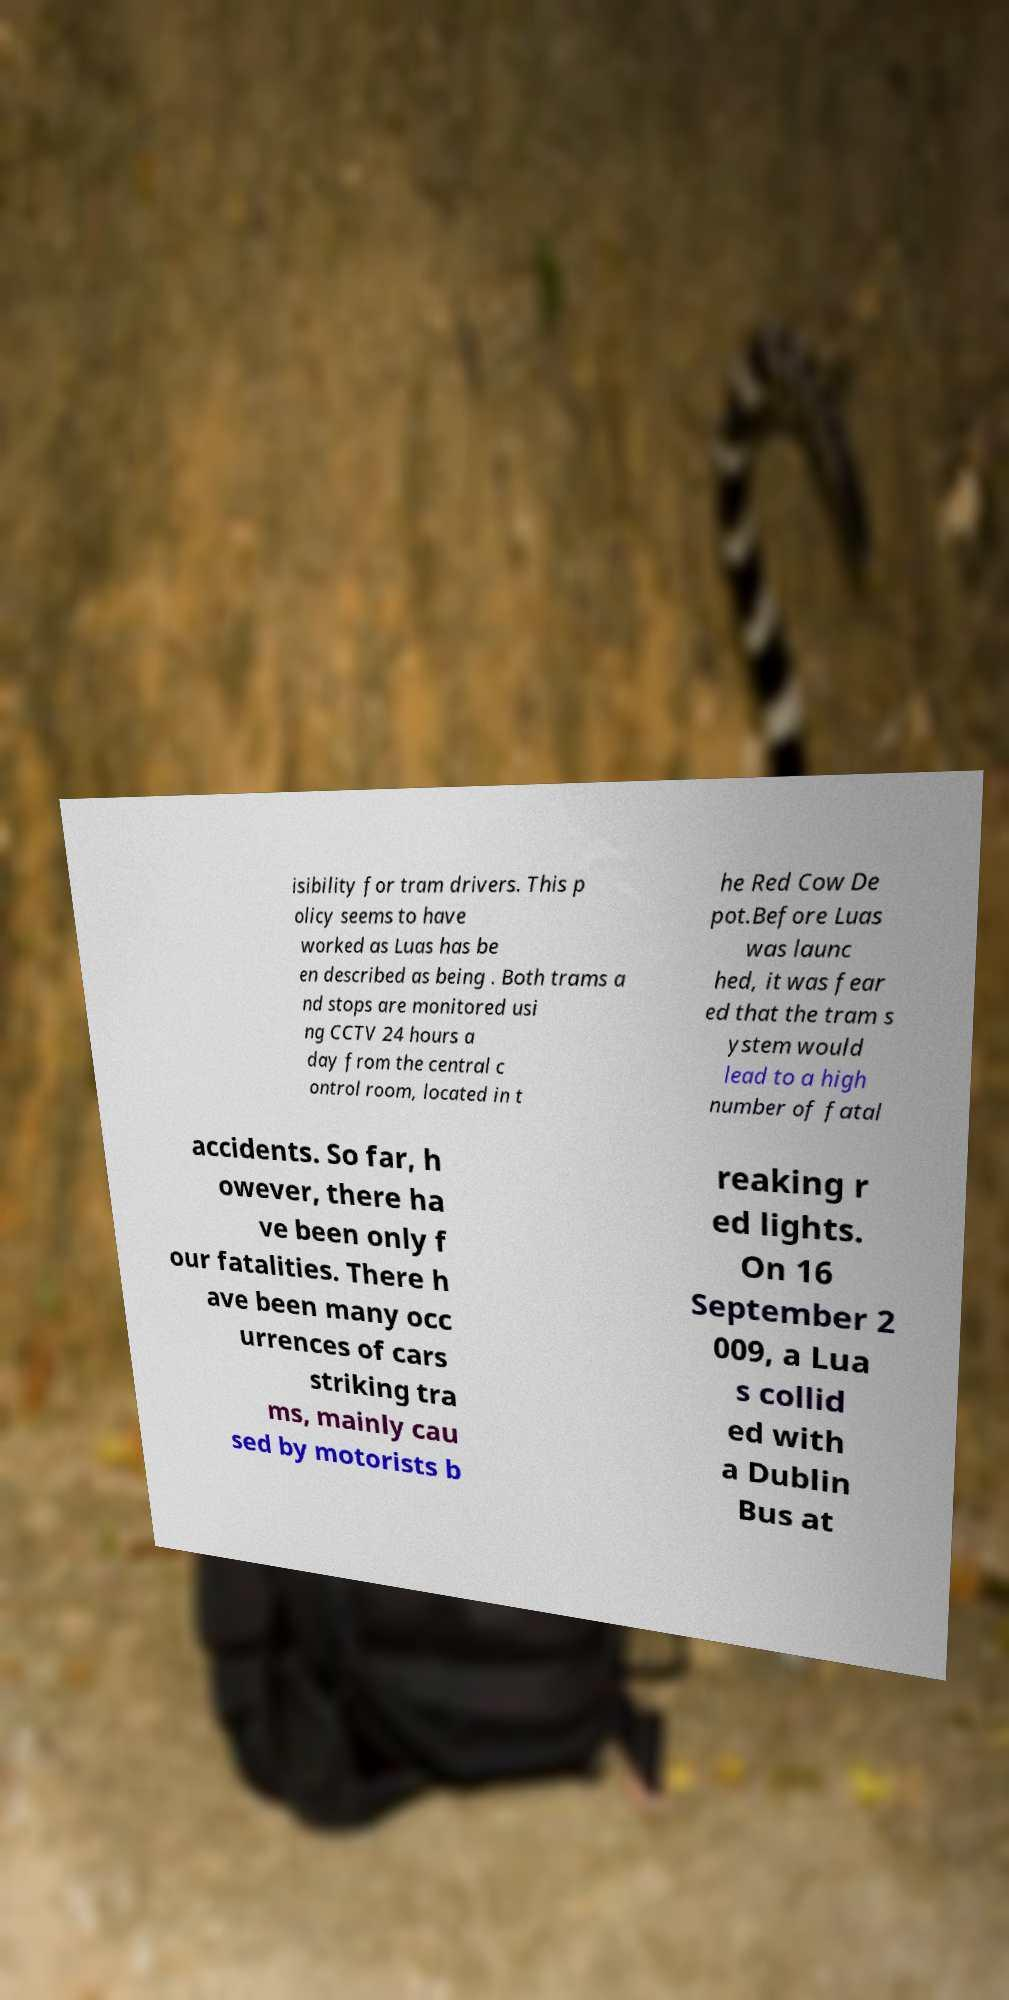Can you accurately transcribe the text from the provided image for me? isibility for tram drivers. This p olicy seems to have worked as Luas has be en described as being . Both trams a nd stops are monitored usi ng CCTV 24 hours a day from the central c ontrol room, located in t he Red Cow De pot.Before Luas was launc hed, it was fear ed that the tram s ystem would lead to a high number of fatal accidents. So far, h owever, there ha ve been only f our fatalities. There h ave been many occ urrences of cars striking tra ms, mainly cau sed by motorists b reaking r ed lights. On 16 September 2 009, a Lua s collid ed with a Dublin Bus at 